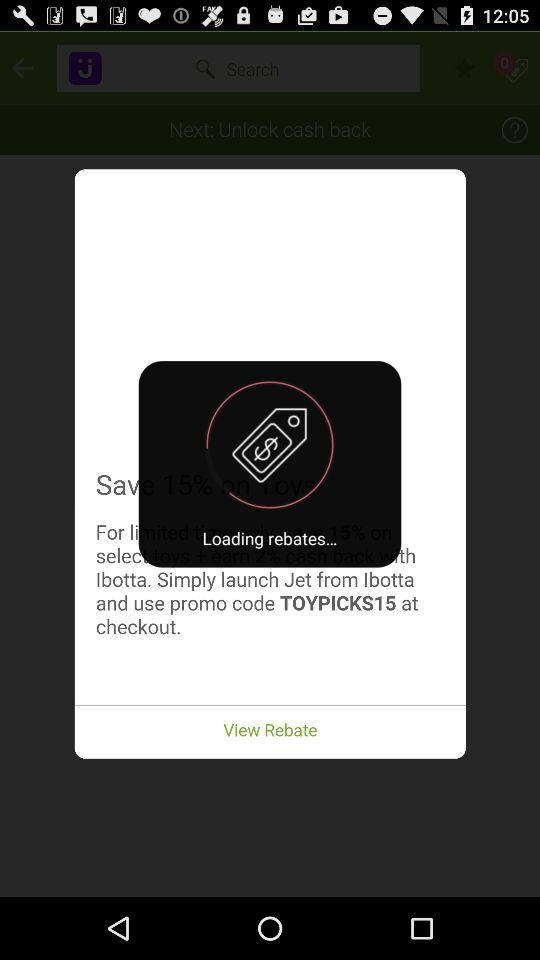What is the given promo code at checkout? The given promo code is "TOYPICKS15". 